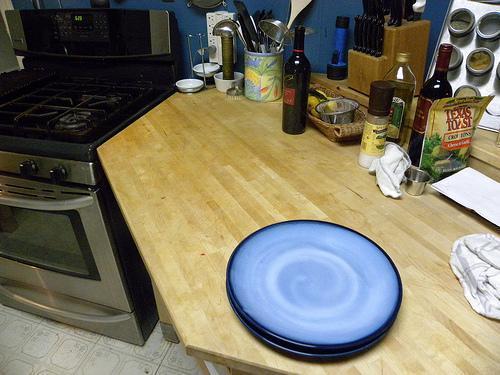How many rags are on the counter?
Give a very brief answer. 2. How many knobs can be seen on the oven?
Give a very brief answer. 2. 